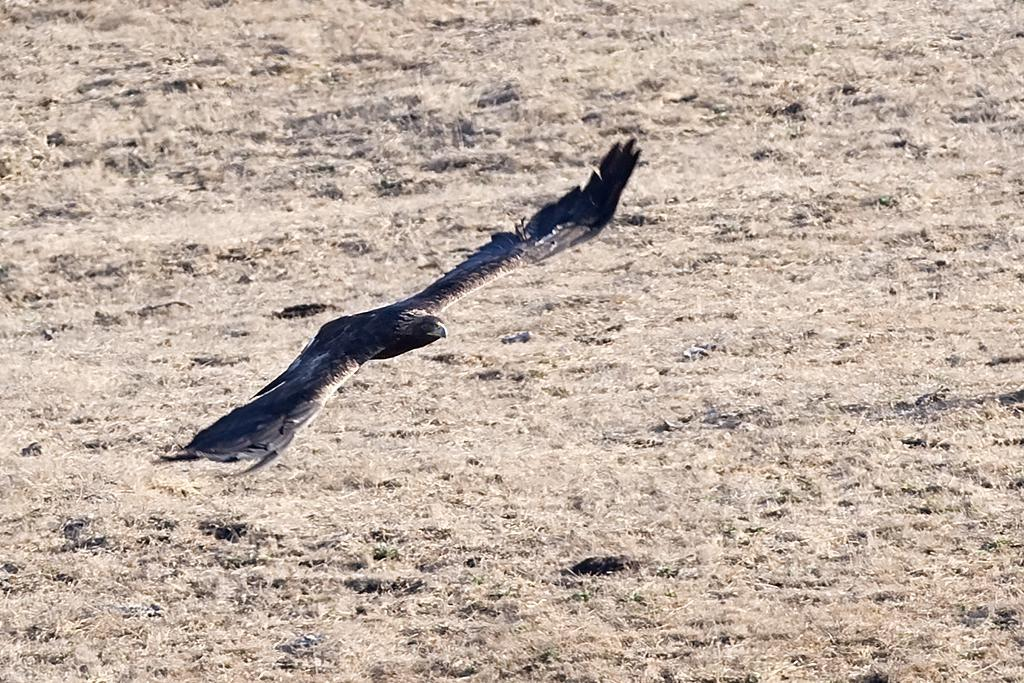What type of animal can be seen in the image? There is a bird in the image. What is the bird doing in the image? The bird is flying in the air. What can be seen in the background of the image? There is ground visible in the background of the image. How many pies are on the bird's bed in the image? There is no bed or pies present in the image; it features a bird flying in the air. 